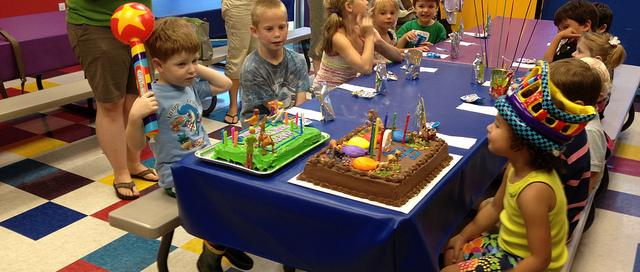What relationship might these two children with the birthday cakes likely have? Please explain your reasoning. they're twins. The other options don't really fit except for d. they might merely be children in the same class. 